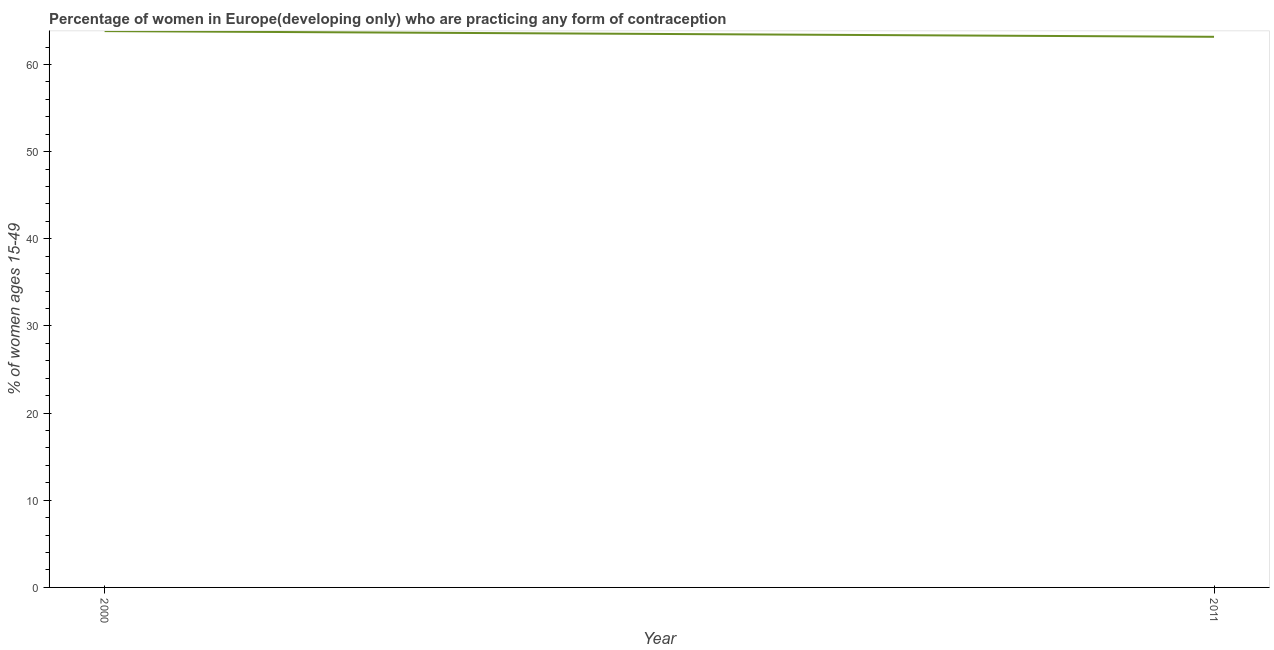What is the contraceptive prevalence in 2011?
Keep it short and to the point. 63.18. Across all years, what is the maximum contraceptive prevalence?
Your answer should be very brief. 63.84. Across all years, what is the minimum contraceptive prevalence?
Give a very brief answer. 63.18. What is the sum of the contraceptive prevalence?
Your answer should be very brief. 127.02. What is the difference between the contraceptive prevalence in 2000 and 2011?
Your response must be concise. 0.65. What is the average contraceptive prevalence per year?
Give a very brief answer. 63.51. What is the median contraceptive prevalence?
Your response must be concise. 63.51. In how many years, is the contraceptive prevalence greater than 56 %?
Provide a short and direct response. 2. Do a majority of the years between 2011 and 2000 (inclusive) have contraceptive prevalence greater than 58 %?
Keep it short and to the point. No. What is the ratio of the contraceptive prevalence in 2000 to that in 2011?
Your answer should be compact. 1.01. Is the contraceptive prevalence in 2000 less than that in 2011?
Ensure brevity in your answer.  No. In how many years, is the contraceptive prevalence greater than the average contraceptive prevalence taken over all years?
Make the answer very short. 1. How many years are there in the graph?
Provide a short and direct response. 2. What is the difference between two consecutive major ticks on the Y-axis?
Keep it short and to the point. 10. Does the graph contain any zero values?
Make the answer very short. No. What is the title of the graph?
Offer a very short reply. Percentage of women in Europe(developing only) who are practicing any form of contraception. What is the label or title of the Y-axis?
Your answer should be very brief. % of women ages 15-49. What is the % of women ages 15-49 in 2000?
Give a very brief answer. 63.84. What is the % of women ages 15-49 of 2011?
Ensure brevity in your answer.  63.18. What is the difference between the % of women ages 15-49 in 2000 and 2011?
Provide a succinct answer. 0.65. 